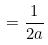Convert formula to latex. <formula><loc_0><loc_0><loc_500><loc_500>= \frac { 1 } { 2 a }</formula> 